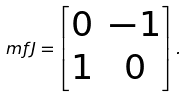<formula> <loc_0><loc_0><loc_500><loc_500>\ m f { J } = \begin{bmatrix} 0 & - 1 \\ 1 & 0 \\ \end{bmatrix} .</formula> 